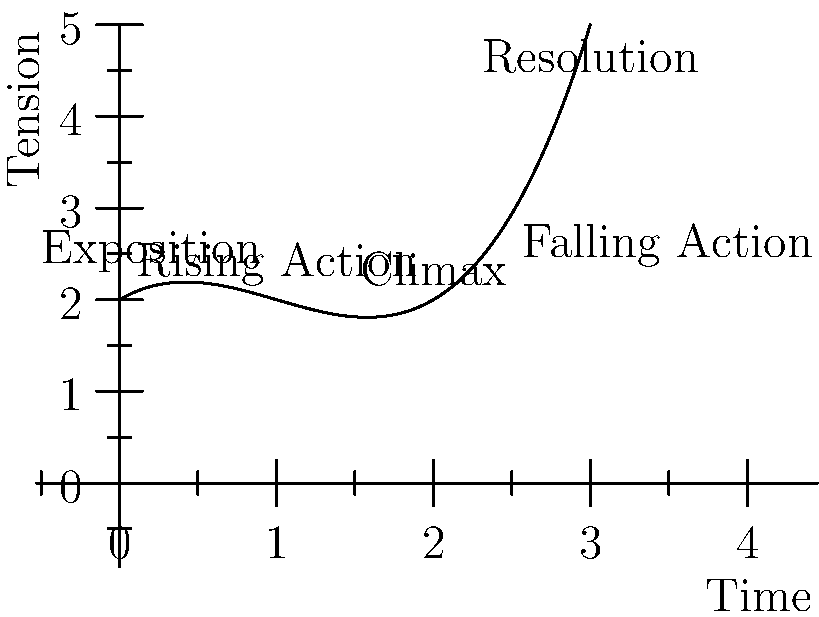Analyze the story arc represented in the line graph. At which point in the narrative does the tension reach its peak, and what literary term is used to describe this moment? To answer this question, let's analyze the graph step-by-step:

1. The x-axis represents time progression in the story, while the y-axis represents the level of tension.

2. The graph shows a curve that rises, peaks, and then falls, which is typical of a story arc.

3. We can see labels for different stages of the story:
   - Exposition: The beginning, where tension is low
   - Rising Action: Where tension starts to increase
   - Climax: The highest point on the graph
   - Falling Action: Where tension begins to decrease
   - Resolution: The end, where tension returns to a lower level

4. The question asks for the point where tension reaches its peak. Looking at the graph, we can see that the highest point is labeled "Climax."

5. In literary terms, the moment of highest tension in a story is indeed called the "climax." This is where the conflict reaches its most intense point and the story's main turning point occurs.

Therefore, the tension reaches its peak at the point labeled "Climax" on the graph, and this moment is referred to as the climax in literary terminology.
Answer: Climax 